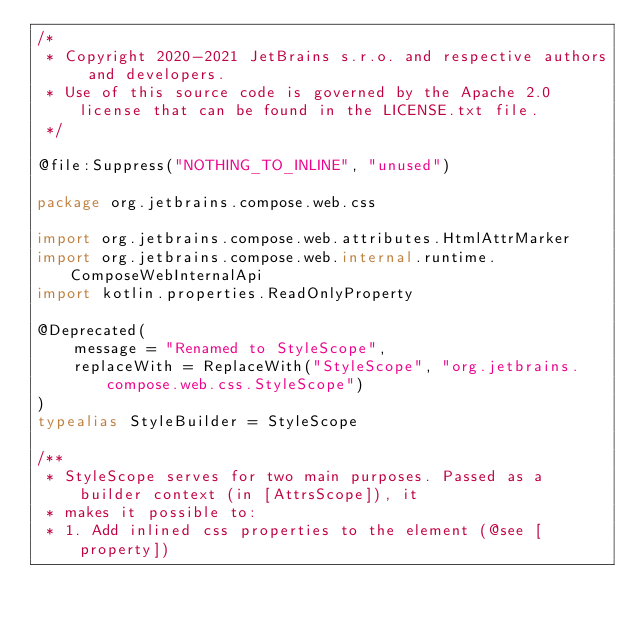<code> <loc_0><loc_0><loc_500><loc_500><_Kotlin_>/*
 * Copyright 2020-2021 JetBrains s.r.o. and respective authors and developers.
 * Use of this source code is governed by the Apache 2.0 license that can be found in the LICENSE.txt file.
 */

@file:Suppress("NOTHING_TO_INLINE", "unused")

package org.jetbrains.compose.web.css

import org.jetbrains.compose.web.attributes.HtmlAttrMarker
import org.jetbrains.compose.web.internal.runtime.ComposeWebInternalApi
import kotlin.properties.ReadOnlyProperty

@Deprecated(
    message = "Renamed to StyleScope",
    replaceWith = ReplaceWith("StyleScope", "org.jetbrains.compose.web.css.StyleScope")
)
typealias StyleBuilder = StyleScope

/**
 * StyleScope serves for two main purposes. Passed as a builder context (in [AttrsScope]), it
 * makes it possible to:
 * 1. Add inlined css properties to the element (@see [property])</code> 